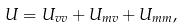Convert formula to latex. <formula><loc_0><loc_0><loc_500><loc_500>U = U _ { v v } + U _ { m v } + U _ { m m } ,</formula> 